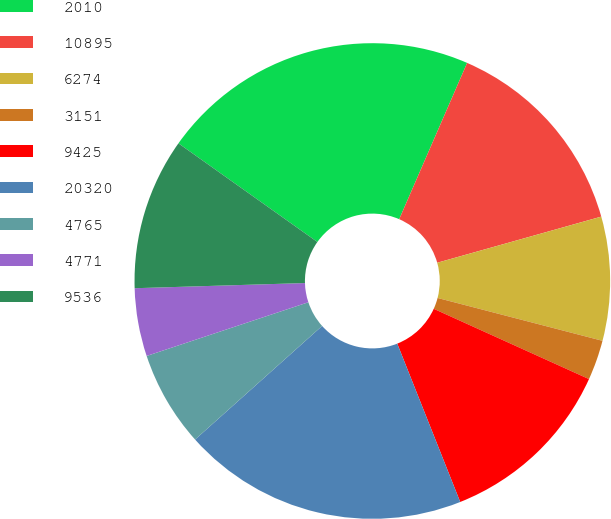Convert chart to OTSL. <chart><loc_0><loc_0><loc_500><loc_500><pie_chart><fcel>2010<fcel>10895<fcel>6274<fcel>3151<fcel>9425<fcel>20320<fcel>4765<fcel>4771<fcel>9536<nl><fcel>21.7%<fcel>14.11%<fcel>8.41%<fcel>2.72%<fcel>12.21%<fcel>19.41%<fcel>6.51%<fcel>4.62%<fcel>10.31%<nl></chart> 